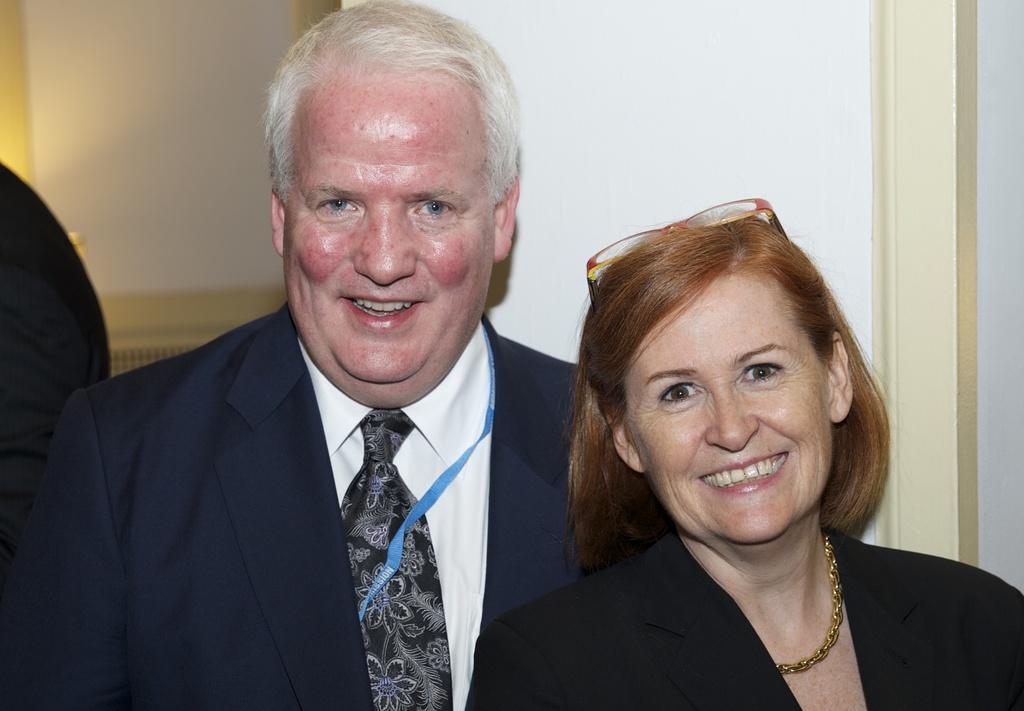How would you summarize this image in a sentence or two? A man and woman are smiling. Background there is a wall. 